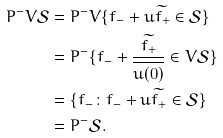<formula> <loc_0><loc_0><loc_500><loc_500>P ^ { - } V \mathcal { S } & = P ^ { - } V \{ f _ { - } + u \widetilde { f _ { + } } \in \mathcal { S } \} \\ & = P ^ { - } \{ f _ { - } + \frac { \widetilde { f _ { + } } } { \overline { u ( 0 ) } } \in V \mathcal { S } \} \\ & = \{ f _ { - } \colon f _ { - } + u \widetilde { f _ { + } } \in \mathcal { S } \} \\ & = P ^ { - } \mathcal { S } .</formula> 